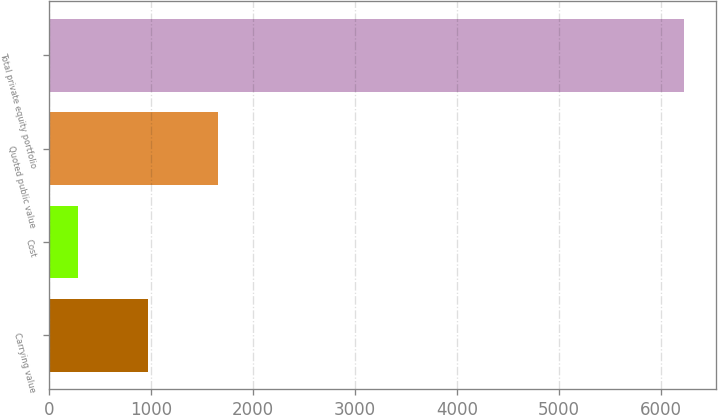Convert chart. <chart><loc_0><loc_0><loc_500><loc_500><bar_chart><fcel>Carrying value<fcel>Cost<fcel>Quoted public value<fcel>Total private equity portfolio<nl><fcel>974.5<fcel>288<fcel>1661<fcel>6231<nl></chart> 